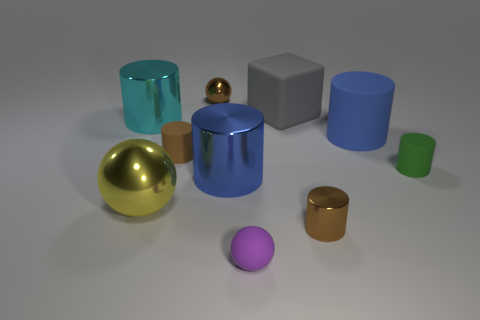Is the shape of the green matte object the same as the yellow object?
Your answer should be compact. No. What number of rubber objects are either blocks or green cylinders?
Provide a succinct answer. 2. Is there a cyan cylinder of the same size as the gray rubber thing?
Your answer should be compact. Yes. There is a large object that is the same color as the large rubber cylinder; what is its shape?
Make the answer very short. Cylinder. How many brown cylinders have the same size as the purple object?
Provide a short and direct response. 2. Does the shiny sphere in front of the gray cube have the same size as the metal cylinder to the right of the small rubber sphere?
Provide a succinct answer. No. What number of objects are purple balls or tiny brown things to the right of the gray rubber object?
Provide a short and direct response. 2. What is the color of the small matte ball?
Keep it short and to the point. Purple. The big blue thing that is to the left of the big blue cylinder that is on the right side of the small metal object that is in front of the small green cylinder is made of what material?
Give a very brief answer. Metal. The ball that is the same material as the cube is what size?
Give a very brief answer. Small. 